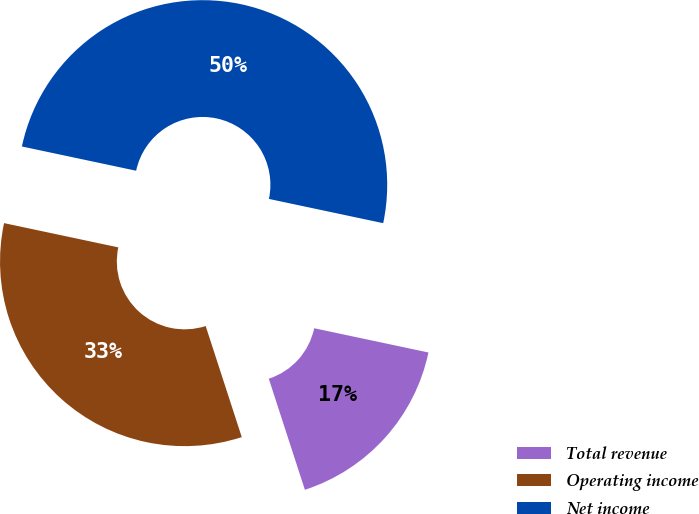Convert chart to OTSL. <chart><loc_0><loc_0><loc_500><loc_500><pie_chart><fcel>Total revenue<fcel>Operating income<fcel>Net income<nl><fcel>16.67%<fcel>33.33%<fcel>50.0%<nl></chart> 